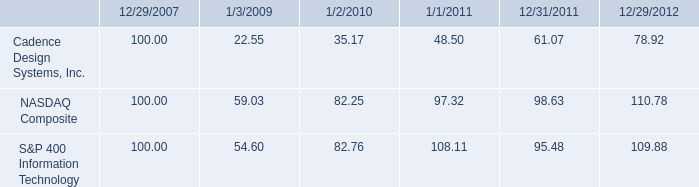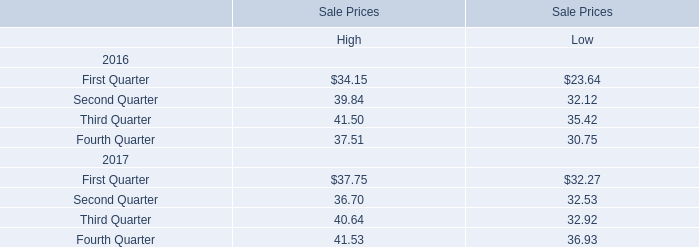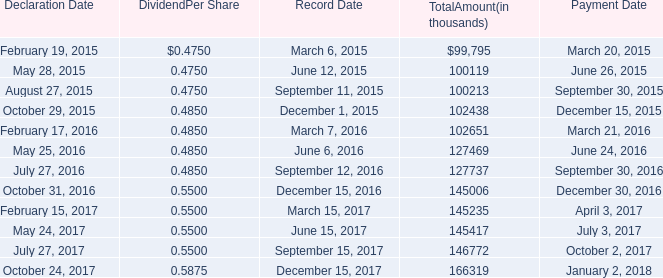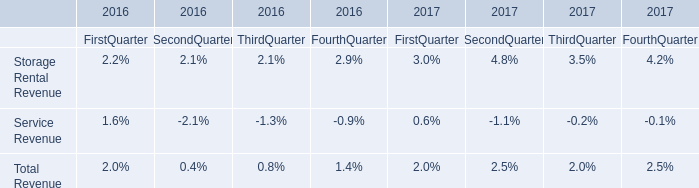what is the roi of nasdaq composite from 2008 to 2012? 
Computations: ((110.78 - 100) / 100)
Answer: 0.1078. 